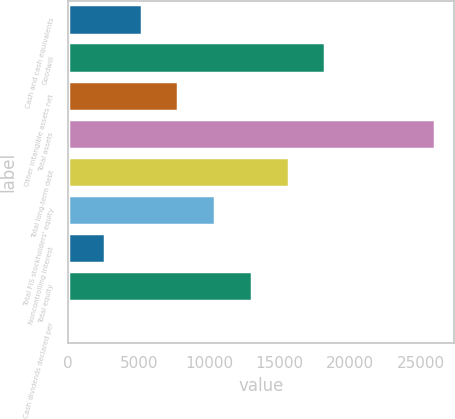<chart> <loc_0><loc_0><loc_500><loc_500><bar_chart><fcel>Cash and cash equivalents<fcel>Goodwill<fcel>Other intangible assets net<fcel>Total assets<fcel>Total long-term debt<fcel>Total FIS stockholders' equity<fcel>Noncontrolling interest<fcel>Total equity<fcel>Cash dividends declared per<nl><fcel>5207.04<fcel>18222<fcel>7810.04<fcel>26031<fcel>15619<fcel>10413<fcel>2604.04<fcel>13016<fcel>1.04<nl></chart> 